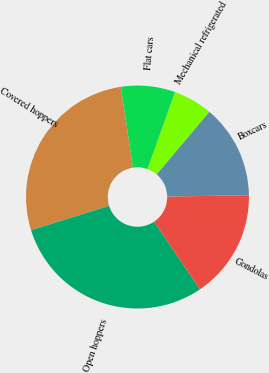Convert chart to OTSL. <chart><loc_0><loc_0><loc_500><loc_500><pie_chart><fcel>Covered hoppers<fcel>Open hoppers<fcel>Gondolas<fcel>Boxcars<fcel>Mechanical refrigerated<fcel>Flat cars<nl><fcel>27.44%<fcel>29.64%<fcel>15.8%<fcel>13.6%<fcel>5.67%<fcel>7.86%<nl></chart> 